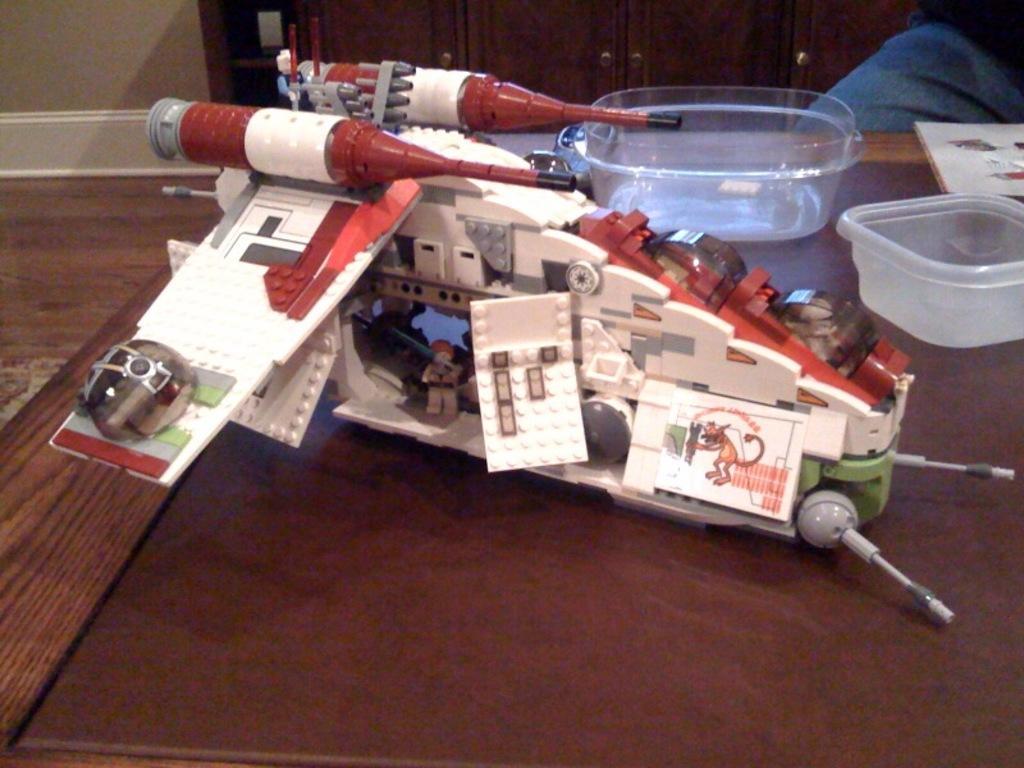Describe this image in one or two sentences. In this picture we an see a toy, a book and few bowls, in the background we can see cupboards and a wall. 